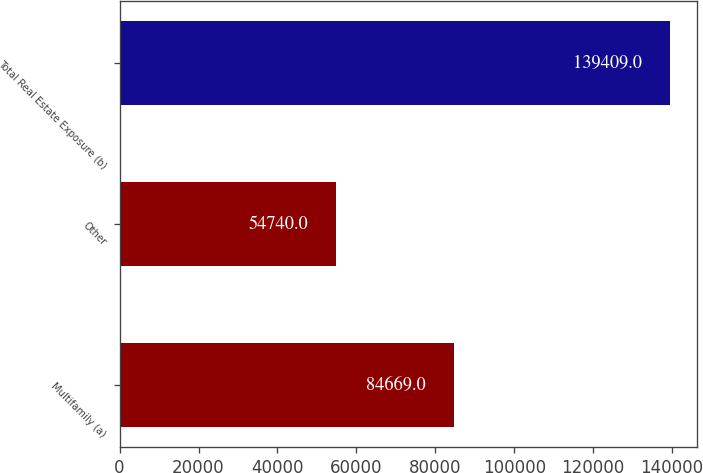Convert chart. <chart><loc_0><loc_0><loc_500><loc_500><bar_chart><fcel>Multifamily (a)<fcel>Other<fcel>Total Real Estate Exposure (b)<nl><fcel>84669<fcel>54740<fcel>139409<nl></chart> 